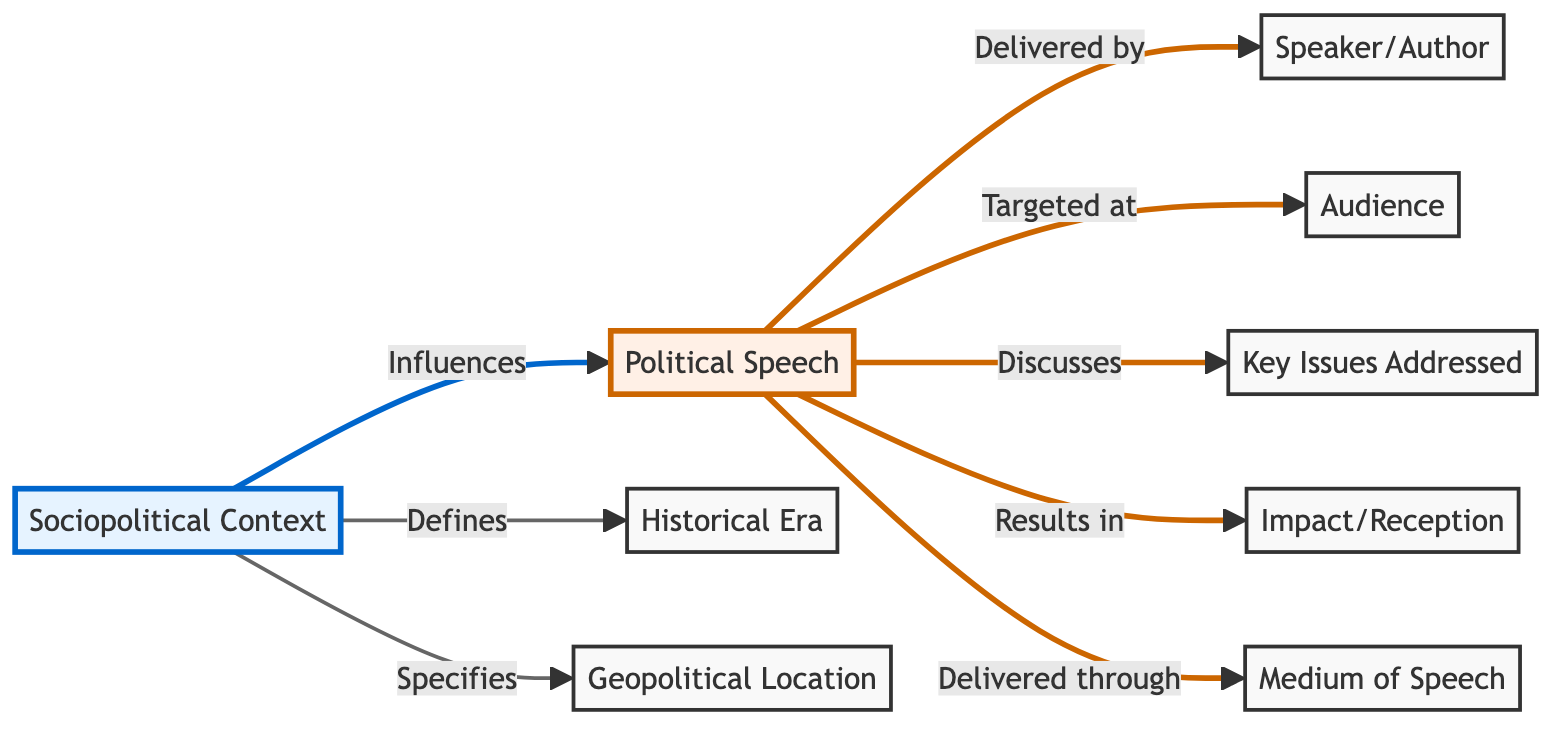What influences the political speech? The diagram shows that the sociopolitical context influences the political speech, indicating that the circumstances surrounding the speech shape its content and delivery.
Answer: Sociopolitical Context Who delivers the political speech? According to the diagram, the political speech is delivered by the speaker or author, making them a central figure in the communication.
Answer: Speaker/Author What defines the historical era? The diagram illustrates that the sociopolitical context defines the historical era, suggesting that the surrounding conditions at the time influence what era it is.
Answer: Sociopolitical Context What key issues are addressed in the speech? The diagram indicates that the political speech discusses key issues, meaning that amidst the delivery, certain significant topics are covered.
Answer: Key Issues Addressed How many elements influence the political speech? Counting from the diagram, we see there are five significant elements influencing or related to the political speech, which forms the basis of understanding its overall context.
Answer: Five What results from the political speech? The diagram depicts that the political speech results in impact or reception, indicating the effect it has on its audience and beyond.
Answer: Impact/Reception What specifies the geopolitical location? The sociopolitical context specifies the geopolitical location, highlighting that the setting is an integral part of understanding the speech.
Answer: Sociopolitical Context Through what medium is the speech delivered? The diagram shows that the medium of speech is how the political speech is delivered, signifying the channels or formats used in its communication.
Answer: Medium of Speech Who is the targeted audience? The diagram illustrates that the political speech is targeted at the audience, suggesting that understanding the intended recipients is vital.
Answer: Audience 